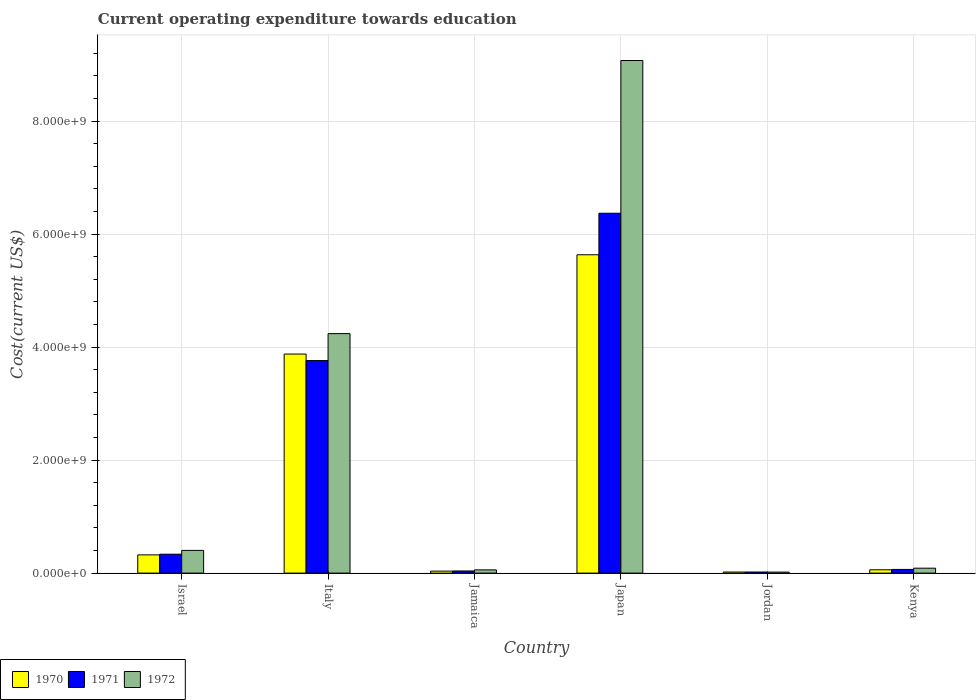How many different coloured bars are there?
Give a very brief answer. 3. Are the number of bars per tick equal to the number of legend labels?
Ensure brevity in your answer.  Yes. What is the label of the 4th group of bars from the left?
Ensure brevity in your answer.  Japan. What is the expenditure towards education in 1972 in Jordan?
Provide a short and direct response. 1.76e+07. Across all countries, what is the maximum expenditure towards education in 1970?
Offer a very short reply. 5.63e+09. Across all countries, what is the minimum expenditure towards education in 1970?
Give a very brief answer. 1.91e+07. In which country was the expenditure towards education in 1970 minimum?
Ensure brevity in your answer.  Jordan. What is the total expenditure towards education in 1970 in the graph?
Your answer should be compact. 9.95e+09. What is the difference between the expenditure towards education in 1971 in Japan and that in Jordan?
Offer a terse response. 6.35e+09. What is the difference between the expenditure towards education in 1972 in Jamaica and the expenditure towards education in 1970 in Kenya?
Provide a short and direct response. -1.37e+06. What is the average expenditure towards education in 1970 per country?
Offer a terse response. 1.66e+09. What is the difference between the expenditure towards education of/in 1970 and expenditure towards education of/in 1971 in Jordan?
Make the answer very short. -3.14e+05. What is the ratio of the expenditure towards education in 1972 in Japan to that in Kenya?
Give a very brief answer. 104.19. Is the expenditure towards education in 1972 in Jordan less than that in Kenya?
Give a very brief answer. Yes. Is the difference between the expenditure towards education in 1970 in Jamaica and Japan greater than the difference between the expenditure towards education in 1971 in Jamaica and Japan?
Offer a terse response. Yes. What is the difference between the highest and the second highest expenditure towards education in 1970?
Provide a short and direct response. 1.76e+09. What is the difference between the highest and the lowest expenditure towards education in 1970?
Provide a succinct answer. 5.62e+09. In how many countries, is the expenditure towards education in 1971 greater than the average expenditure towards education in 1971 taken over all countries?
Ensure brevity in your answer.  2. What does the 2nd bar from the left in Kenya represents?
Ensure brevity in your answer.  1971. What does the 2nd bar from the right in Jordan represents?
Ensure brevity in your answer.  1971. How many bars are there?
Your answer should be compact. 18. What is the difference between two consecutive major ticks on the Y-axis?
Provide a succinct answer. 2.00e+09. Are the values on the major ticks of Y-axis written in scientific E-notation?
Provide a short and direct response. Yes. Does the graph contain grids?
Offer a very short reply. Yes. How many legend labels are there?
Your answer should be compact. 3. How are the legend labels stacked?
Your response must be concise. Horizontal. What is the title of the graph?
Offer a very short reply. Current operating expenditure towards education. Does "1984" appear as one of the legend labels in the graph?
Your answer should be compact. No. What is the label or title of the X-axis?
Provide a succinct answer. Country. What is the label or title of the Y-axis?
Offer a terse response. Cost(current US$). What is the Cost(current US$) in 1970 in Israel?
Ensure brevity in your answer.  3.22e+08. What is the Cost(current US$) in 1971 in Israel?
Keep it short and to the point. 3.34e+08. What is the Cost(current US$) in 1972 in Israel?
Give a very brief answer. 4.02e+08. What is the Cost(current US$) in 1970 in Italy?
Your answer should be very brief. 3.88e+09. What is the Cost(current US$) in 1971 in Italy?
Your answer should be very brief. 3.76e+09. What is the Cost(current US$) in 1972 in Italy?
Keep it short and to the point. 4.24e+09. What is the Cost(current US$) of 1970 in Jamaica?
Offer a terse response. 3.49e+07. What is the Cost(current US$) in 1971 in Jamaica?
Offer a terse response. 3.77e+07. What is the Cost(current US$) in 1972 in Jamaica?
Offer a terse response. 5.71e+07. What is the Cost(current US$) in 1970 in Japan?
Your answer should be compact. 5.63e+09. What is the Cost(current US$) of 1971 in Japan?
Offer a terse response. 6.37e+09. What is the Cost(current US$) in 1972 in Japan?
Keep it short and to the point. 9.07e+09. What is the Cost(current US$) of 1970 in Jordan?
Offer a terse response. 1.91e+07. What is the Cost(current US$) in 1971 in Jordan?
Offer a very short reply. 1.94e+07. What is the Cost(current US$) of 1972 in Jordan?
Give a very brief answer. 1.76e+07. What is the Cost(current US$) of 1970 in Kenya?
Your answer should be compact. 5.85e+07. What is the Cost(current US$) in 1971 in Kenya?
Your response must be concise. 6.49e+07. What is the Cost(current US$) of 1972 in Kenya?
Provide a short and direct response. 8.71e+07. Across all countries, what is the maximum Cost(current US$) in 1970?
Your answer should be compact. 5.63e+09. Across all countries, what is the maximum Cost(current US$) in 1971?
Keep it short and to the point. 6.37e+09. Across all countries, what is the maximum Cost(current US$) of 1972?
Provide a succinct answer. 9.07e+09. Across all countries, what is the minimum Cost(current US$) of 1970?
Make the answer very short. 1.91e+07. Across all countries, what is the minimum Cost(current US$) of 1971?
Ensure brevity in your answer.  1.94e+07. Across all countries, what is the minimum Cost(current US$) in 1972?
Give a very brief answer. 1.76e+07. What is the total Cost(current US$) of 1970 in the graph?
Provide a short and direct response. 9.95e+09. What is the total Cost(current US$) in 1971 in the graph?
Give a very brief answer. 1.06e+1. What is the total Cost(current US$) in 1972 in the graph?
Offer a terse response. 1.39e+1. What is the difference between the Cost(current US$) of 1970 in Israel and that in Italy?
Ensure brevity in your answer.  -3.55e+09. What is the difference between the Cost(current US$) in 1971 in Israel and that in Italy?
Offer a very short reply. -3.43e+09. What is the difference between the Cost(current US$) of 1972 in Israel and that in Italy?
Your answer should be compact. -3.84e+09. What is the difference between the Cost(current US$) of 1970 in Israel and that in Jamaica?
Ensure brevity in your answer.  2.87e+08. What is the difference between the Cost(current US$) in 1971 in Israel and that in Jamaica?
Your answer should be compact. 2.97e+08. What is the difference between the Cost(current US$) of 1972 in Israel and that in Jamaica?
Provide a succinct answer. 3.45e+08. What is the difference between the Cost(current US$) in 1970 in Israel and that in Japan?
Offer a terse response. -5.31e+09. What is the difference between the Cost(current US$) in 1971 in Israel and that in Japan?
Give a very brief answer. -6.03e+09. What is the difference between the Cost(current US$) of 1972 in Israel and that in Japan?
Your response must be concise. -8.67e+09. What is the difference between the Cost(current US$) in 1970 in Israel and that in Jordan?
Ensure brevity in your answer.  3.03e+08. What is the difference between the Cost(current US$) of 1971 in Israel and that in Jordan?
Provide a succinct answer. 3.15e+08. What is the difference between the Cost(current US$) in 1972 in Israel and that in Jordan?
Offer a terse response. 3.84e+08. What is the difference between the Cost(current US$) of 1970 in Israel and that in Kenya?
Your answer should be very brief. 2.64e+08. What is the difference between the Cost(current US$) in 1971 in Israel and that in Kenya?
Your answer should be compact. 2.70e+08. What is the difference between the Cost(current US$) of 1972 in Israel and that in Kenya?
Your answer should be compact. 3.15e+08. What is the difference between the Cost(current US$) in 1970 in Italy and that in Jamaica?
Your answer should be very brief. 3.84e+09. What is the difference between the Cost(current US$) of 1971 in Italy and that in Jamaica?
Provide a succinct answer. 3.72e+09. What is the difference between the Cost(current US$) in 1972 in Italy and that in Jamaica?
Ensure brevity in your answer.  4.18e+09. What is the difference between the Cost(current US$) of 1970 in Italy and that in Japan?
Offer a terse response. -1.76e+09. What is the difference between the Cost(current US$) in 1971 in Italy and that in Japan?
Your response must be concise. -2.61e+09. What is the difference between the Cost(current US$) in 1972 in Italy and that in Japan?
Give a very brief answer. -4.83e+09. What is the difference between the Cost(current US$) in 1970 in Italy and that in Jordan?
Your answer should be compact. 3.86e+09. What is the difference between the Cost(current US$) of 1971 in Italy and that in Jordan?
Your answer should be very brief. 3.74e+09. What is the difference between the Cost(current US$) in 1972 in Italy and that in Jordan?
Your response must be concise. 4.22e+09. What is the difference between the Cost(current US$) in 1970 in Italy and that in Kenya?
Provide a succinct answer. 3.82e+09. What is the difference between the Cost(current US$) in 1971 in Italy and that in Kenya?
Ensure brevity in your answer.  3.70e+09. What is the difference between the Cost(current US$) of 1972 in Italy and that in Kenya?
Provide a succinct answer. 4.15e+09. What is the difference between the Cost(current US$) of 1970 in Jamaica and that in Japan?
Keep it short and to the point. -5.60e+09. What is the difference between the Cost(current US$) in 1971 in Jamaica and that in Japan?
Provide a succinct answer. -6.33e+09. What is the difference between the Cost(current US$) of 1972 in Jamaica and that in Japan?
Provide a short and direct response. -9.02e+09. What is the difference between the Cost(current US$) in 1970 in Jamaica and that in Jordan?
Offer a very short reply. 1.58e+07. What is the difference between the Cost(current US$) of 1971 in Jamaica and that in Jordan?
Make the answer very short. 1.83e+07. What is the difference between the Cost(current US$) in 1972 in Jamaica and that in Jordan?
Provide a succinct answer. 3.95e+07. What is the difference between the Cost(current US$) of 1970 in Jamaica and that in Kenya?
Provide a short and direct response. -2.35e+07. What is the difference between the Cost(current US$) in 1971 in Jamaica and that in Kenya?
Give a very brief answer. -2.72e+07. What is the difference between the Cost(current US$) of 1972 in Jamaica and that in Kenya?
Provide a short and direct response. -3.00e+07. What is the difference between the Cost(current US$) in 1970 in Japan and that in Jordan?
Give a very brief answer. 5.62e+09. What is the difference between the Cost(current US$) in 1971 in Japan and that in Jordan?
Your answer should be compact. 6.35e+09. What is the difference between the Cost(current US$) of 1972 in Japan and that in Jordan?
Keep it short and to the point. 9.05e+09. What is the difference between the Cost(current US$) in 1970 in Japan and that in Kenya?
Ensure brevity in your answer.  5.58e+09. What is the difference between the Cost(current US$) of 1971 in Japan and that in Kenya?
Your response must be concise. 6.30e+09. What is the difference between the Cost(current US$) of 1972 in Japan and that in Kenya?
Offer a terse response. 8.99e+09. What is the difference between the Cost(current US$) in 1970 in Jordan and that in Kenya?
Ensure brevity in your answer.  -3.94e+07. What is the difference between the Cost(current US$) in 1971 in Jordan and that in Kenya?
Ensure brevity in your answer.  -4.55e+07. What is the difference between the Cost(current US$) in 1972 in Jordan and that in Kenya?
Provide a short and direct response. -6.95e+07. What is the difference between the Cost(current US$) of 1970 in Israel and the Cost(current US$) of 1971 in Italy?
Provide a succinct answer. -3.44e+09. What is the difference between the Cost(current US$) of 1970 in Israel and the Cost(current US$) of 1972 in Italy?
Provide a short and direct response. -3.92e+09. What is the difference between the Cost(current US$) in 1971 in Israel and the Cost(current US$) in 1972 in Italy?
Offer a terse response. -3.90e+09. What is the difference between the Cost(current US$) of 1970 in Israel and the Cost(current US$) of 1971 in Jamaica?
Provide a short and direct response. 2.85e+08. What is the difference between the Cost(current US$) of 1970 in Israel and the Cost(current US$) of 1972 in Jamaica?
Your response must be concise. 2.65e+08. What is the difference between the Cost(current US$) of 1971 in Israel and the Cost(current US$) of 1972 in Jamaica?
Make the answer very short. 2.77e+08. What is the difference between the Cost(current US$) in 1970 in Israel and the Cost(current US$) in 1971 in Japan?
Your answer should be very brief. -6.05e+09. What is the difference between the Cost(current US$) of 1970 in Israel and the Cost(current US$) of 1972 in Japan?
Ensure brevity in your answer.  -8.75e+09. What is the difference between the Cost(current US$) of 1971 in Israel and the Cost(current US$) of 1972 in Japan?
Give a very brief answer. -8.74e+09. What is the difference between the Cost(current US$) of 1970 in Israel and the Cost(current US$) of 1971 in Jordan?
Offer a terse response. 3.03e+08. What is the difference between the Cost(current US$) of 1970 in Israel and the Cost(current US$) of 1972 in Jordan?
Offer a very short reply. 3.05e+08. What is the difference between the Cost(current US$) of 1971 in Israel and the Cost(current US$) of 1972 in Jordan?
Provide a succinct answer. 3.17e+08. What is the difference between the Cost(current US$) of 1970 in Israel and the Cost(current US$) of 1971 in Kenya?
Your response must be concise. 2.57e+08. What is the difference between the Cost(current US$) of 1970 in Israel and the Cost(current US$) of 1972 in Kenya?
Provide a succinct answer. 2.35e+08. What is the difference between the Cost(current US$) in 1971 in Israel and the Cost(current US$) in 1972 in Kenya?
Make the answer very short. 2.47e+08. What is the difference between the Cost(current US$) in 1970 in Italy and the Cost(current US$) in 1971 in Jamaica?
Your answer should be compact. 3.84e+09. What is the difference between the Cost(current US$) in 1970 in Italy and the Cost(current US$) in 1972 in Jamaica?
Provide a succinct answer. 3.82e+09. What is the difference between the Cost(current US$) of 1971 in Italy and the Cost(current US$) of 1972 in Jamaica?
Give a very brief answer. 3.70e+09. What is the difference between the Cost(current US$) in 1970 in Italy and the Cost(current US$) in 1971 in Japan?
Keep it short and to the point. -2.49e+09. What is the difference between the Cost(current US$) in 1970 in Italy and the Cost(current US$) in 1972 in Japan?
Provide a short and direct response. -5.20e+09. What is the difference between the Cost(current US$) of 1971 in Italy and the Cost(current US$) of 1972 in Japan?
Provide a short and direct response. -5.31e+09. What is the difference between the Cost(current US$) of 1970 in Italy and the Cost(current US$) of 1971 in Jordan?
Your answer should be compact. 3.86e+09. What is the difference between the Cost(current US$) of 1970 in Italy and the Cost(current US$) of 1972 in Jordan?
Your answer should be compact. 3.86e+09. What is the difference between the Cost(current US$) of 1971 in Italy and the Cost(current US$) of 1972 in Jordan?
Give a very brief answer. 3.74e+09. What is the difference between the Cost(current US$) in 1970 in Italy and the Cost(current US$) in 1971 in Kenya?
Make the answer very short. 3.81e+09. What is the difference between the Cost(current US$) of 1970 in Italy and the Cost(current US$) of 1972 in Kenya?
Ensure brevity in your answer.  3.79e+09. What is the difference between the Cost(current US$) in 1971 in Italy and the Cost(current US$) in 1972 in Kenya?
Keep it short and to the point. 3.67e+09. What is the difference between the Cost(current US$) of 1970 in Jamaica and the Cost(current US$) of 1971 in Japan?
Your answer should be compact. -6.33e+09. What is the difference between the Cost(current US$) of 1970 in Jamaica and the Cost(current US$) of 1972 in Japan?
Keep it short and to the point. -9.04e+09. What is the difference between the Cost(current US$) in 1971 in Jamaica and the Cost(current US$) in 1972 in Japan?
Provide a short and direct response. -9.03e+09. What is the difference between the Cost(current US$) of 1970 in Jamaica and the Cost(current US$) of 1971 in Jordan?
Give a very brief answer. 1.55e+07. What is the difference between the Cost(current US$) of 1970 in Jamaica and the Cost(current US$) of 1972 in Jordan?
Give a very brief answer. 1.73e+07. What is the difference between the Cost(current US$) in 1971 in Jamaica and the Cost(current US$) in 1972 in Jordan?
Offer a very short reply. 2.01e+07. What is the difference between the Cost(current US$) in 1970 in Jamaica and the Cost(current US$) in 1971 in Kenya?
Give a very brief answer. -3.00e+07. What is the difference between the Cost(current US$) of 1970 in Jamaica and the Cost(current US$) of 1972 in Kenya?
Your answer should be compact. -5.21e+07. What is the difference between the Cost(current US$) of 1971 in Jamaica and the Cost(current US$) of 1972 in Kenya?
Provide a succinct answer. -4.94e+07. What is the difference between the Cost(current US$) in 1970 in Japan and the Cost(current US$) in 1971 in Jordan?
Your answer should be compact. 5.61e+09. What is the difference between the Cost(current US$) of 1970 in Japan and the Cost(current US$) of 1972 in Jordan?
Provide a succinct answer. 5.62e+09. What is the difference between the Cost(current US$) in 1971 in Japan and the Cost(current US$) in 1972 in Jordan?
Ensure brevity in your answer.  6.35e+09. What is the difference between the Cost(current US$) in 1970 in Japan and the Cost(current US$) in 1971 in Kenya?
Provide a short and direct response. 5.57e+09. What is the difference between the Cost(current US$) of 1970 in Japan and the Cost(current US$) of 1972 in Kenya?
Provide a succinct answer. 5.55e+09. What is the difference between the Cost(current US$) of 1971 in Japan and the Cost(current US$) of 1972 in Kenya?
Provide a short and direct response. 6.28e+09. What is the difference between the Cost(current US$) of 1970 in Jordan and the Cost(current US$) of 1971 in Kenya?
Offer a terse response. -4.58e+07. What is the difference between the Cost(current US$) of 1970 in Jordan and the Cost(current US$) of 1972 in Kenya?
Offer a very short reply. -6.80e+07. What is the difference between the Cost(current US$) of 1971 in Jordan and the Cost(current US$) of 1972 in Kenya?
Your answer should be very brief. -6.77e+07. What is the average Cost(current US$) in 1970 per country?
Give a very brief answer. 1.66e+09. What is the average Cost(current US$) of 1971 per country?
Give a very brief answer. 1.76e+09. What is the average Cost(current US$) of 1972 per country?
Keep it short and to the point. 2.31e+09. What is the difference between the Cost(current US$) of 1970 and Cost(current US$) of 1971 in Israel?
Provide a short and direct response. -1.22e+07. What is the difference between the Cost(current US$) of 1970 and Cost(current US$) of 1972 in Israel?
Provide a succinct answer. -7.96e+07. What is the difference between the Cost(current US$) in 1971 and Cost(current US$) in 1972 in Israel?
Your response must be concise. -6.74e+07. What is the difference between the Cost(current US$) of 1970 and Cost(current US$) of 1971 in Italy?
Keep it short and to the point. 1.15e+08. What is the difference between the Cost(current US$) of 1970 and Cost(current US$) of 1972 in Italy?
Give a very brief answer. -3.62e+08. What is the difference between the Cost(current US$) of 1971 and Cost(current US$) of 1972 in Italy?
Provide a short and direct response. -4.77e+08. What is the difference between the Cost(current US$) in 1970 and Cost(current US$) in 1971 in Jamaica?
Offer a terse response. -2.78e+06. What is the difference between the Cost(current US$) of 1970 and Cost(current US$) of 1972 in Jamaica?
Your answer should be very brief. -2.22e+07. What is the difference between the Cost(current US$) in 1971 and Cost(current US$) in 1972 in Jamaica?
Ensure brevity in your answer.  -1.94e+07. What is the difference between the Cost(current US$) in 1970 and Cost(current US$) in 1971 in Japan?
Your answer should be very brief. -7.35e+08. What is the difference between the Cost(current US$) of 1970 and Cost(current US$) of 1972 in Japan?
Your answer should be compact. -3.44e+09. What is the difference between the Cost(current US$) of 1971 and Cost(current US$) of 1972 in Japan?
Provide a short and direct response. -2.70e+09. What is the difference between the Cost(current US$) of 1970 and Cost(current US$) of 1971 in Jordan?
Make the answer very short. -3.14e+05. What is the difference between the Cost(current US$) in 1970 and Cost(current US$) in 1972 in Jordan?
Provide a succinct answer. 1.49e+06. What is the difference between the Cost(current US$) of 1971 and Cost(current US$) of 1972 in Jordan?
Your answer should be very brief. 1.80e+06. What is the difference between the Cost(current US$) in 1970 and Cost(current US$) in 1971 in Kenya?
Give a very brief answer. -6.41e+06. What is the difference between the Cost(current US$) in 1970 and Cost(current US$) in 1972 in Kenya?
Offer a very short reply. -2.86e+07. What is the difference between the Cost(current US$) in 1971 and Cost(current US$) in 1972 in Kenya?
Offer a terse response. -2.22e+07. What is the ratio of the Cost(current US$) of 1970 in Israel to that in Italy?
Your answer should be very brief. 0.08. What is the ratio of the Cost(current US$) of 1971 in Israel to that in Italy?
Make the answer very short. 0.09. What is the ratio of the Cost(current US$) in 1972 in Israel to that in Italy?
Ensure brevity in your answer.  0.09. What is the ratio of the Cost(current US$) in 1970 in Israel to that in Jamaica?
Your answer should be compact. 9.22. What is the ratio of the Cost(current US$) in 1971 in Israel to that in Jamaica?
Your answer should be compact. 8.87. What is the ratio of the Cost(current US$) of 1972 in Israel to that in Jamaica?
Offer a very short reply. 7.04. What is the ratio of the Cost(current US$) of 1970 in Israel to that in Japan?
Ensure brevity in your answer.  0.06. What is the ratio of the Cost(current US$) of 1971 in Israel to that in Japan?
Your answer should be compact. 0.05. What is the ratio of the Cost(current US$) of 1972 in Israel to that in Japan?
Give a very brief answer. 0.04. What is the ratio of the Cost(current US$) of 1970 in Israel to that in Jordan?
Your answer should be very brief. 16.88. What is the ratio of the Cost(current US$) of 1971 in Israel to that in Jordan?
Keep it short and to the point. 17.24. What is the ratio of the Cost(current US$) of 1972 in Israel to that in Jordan?
Your answer should be compact. 22.83. What is the ratio of the Cost(current US$) of 1970 in Israel to that in Kenya?
Provide a short and direct response. 5.51. What is the ratio of the Cost(current US$) in 1971 in Israel to that in Kenya?
Offer a very short reply. 5.15. What is the ratio of the Cost(current US$) in 1972 in Israel to that in Kenya?
Offer a very short reply. 4.62. What is the ratio of the Cost(current US$) of 1970 in Italy to that in Jamaica?
Make the answer very short. 110.97. What is the ratio of the Cost(current US$) of 1971 in Italy to that in Jamaica?
Ensure brevity in your answer.  99.73. What is the ratio of the Cost(current US$) of 1972 in Italy to that in Jamaica?
Offer a terse response. 74.21. What is the ratio of the Cost(current US$) of 1970 in Italy to that in Japan?
Offer a very short reply. 0.69. What is the ratio of the Cost(current US$) of 1971 in Italy to that in Japan?
Your answer should be very brief. 0.59. What is the ratio of the Cost(current US$) in 1972 in Italy to that in Japan?
Make the answer very short. 0.47. What is the ratio of the Cost(current US$) of 1970 in Italy to that in Jordan?
Give a very brief answer. 203.08. What is the ratio of the Cost(current US$) of 1971 in Italy to that in Jordan?
Provide a short and direct response. 193.85. What is the ratio of the Cost(current US$) in 1972 in Italy to that in Jordan?
Offer a terse response. 240.83. What is the ratio of the Cost(current US$) in 1970 in Italy to that in Kenya?
Keep it short and to the point. 66.29. What is the ratio of the Cost(current US$) of 1971 in Italy to that in Kenya?
Provide a succinct answer. 57.97. What is the ratio of the Cost(current US$) in 1972 in Italy to that in Kenya?
Provide a short and direct response. 48.68. What is the ratio of the Cost(current US$) of 1970 in Jamaica to that in Japan?
Your answer should be compact. 0.01. What is the ratio of the Cost(current US$) of 1971 in Jamaica to that in Japan?
Offer a very short reply. 0.01. What is the ratio of the Cost(current US$) in 1972 in Jamaica to that in Japan?
Your answer should be compact. 0.01. What is the ratio of the Cost(current US$) of 1970 in Jamaica to that in Jordan?
Your answer should be compact. 1.83. What is the ratio of the Cost(current US$) of 1971 in Jamaica to that in Jordan?
Your answer should be compact. 1.94. What is the ratio of the Cost(current US$) in 1972 in Jamaica to that in Jordan?
Make the answer very short. 3.25. What is the ratio of the Cost(current US$) in 1970 in Jamaica to that in Kenya?
Provide a succinct answer. 0.6. What is the ratio of the Cost(current US$) in 1971 in Jamaica to that in Kenya?
Your response must be concise. 0.58. What is the ratio of the Cost(current US$) of 1972 in Jamaica to that in Kenya?
Make the answer very short. 0.66. What is the ratio of the Cost(current US$) in 1970 in Japan to that in Jordan?
Your answer should be very brief. 295.14. What is the ratio of the Cost(current US$) of 1971 in Japan to that in Jordan?
Your response must be concise. 328.24. What is the ratio of the Cost(current US$) of 1972 in Japan to that in Jordan?
Provide a succinct answer. 515.5. What is the ratio of the Cost(current US$) of 1970 in Japan to that in Kenya?
Keep it short and to the point. 96.35. What is the ratio of the Cost(current US$) in 1971 in Japan to that in Kenya?
Your response must be concise. 98.15. What is the ratio of the Cost(current US$) in 1972 in Japan to that in Kenya?
Make the answer very short. 104.19. What is the ratio of the Cost(current US$) in 1970 in Jordan to that in Kenya?
Make the answer very short. 0.33. What is the ratio of the Cost(current US$) of 1971 in Jordan to that in Kenya?
Make the answer very short. 0.3. What is the ratio of the Cost(current US$) of 1972 in Jordan to that in Kenya?
Ensure brevity in your answer.  0.2. What is the difference between the highest and the second highest Cost(current US$) of 1970?
Ensure brevity in your answer.  1.76e+09. What is the difference between the highest and the second highest Cost(current US$) of 1971?
Keep it short and to the point. 2.61e+09. What is the difference between the highest and the second highest Cost(current US$) of 1972?
Provide a short and direct response. 4.83e+09. What is the difference between the highest and the lowest Cost(current US$) of 1970?
Your answer should be very brief. 5.62e+09. What is the difference between the highest and the lowest Cost(current US$) in 1971?
Ensure brevity in your answer.  6.35e+09. What is the difference between the highest and the lowest Cost(current US$) of 1972?
Your answer should be compact. 9.05e+09. 